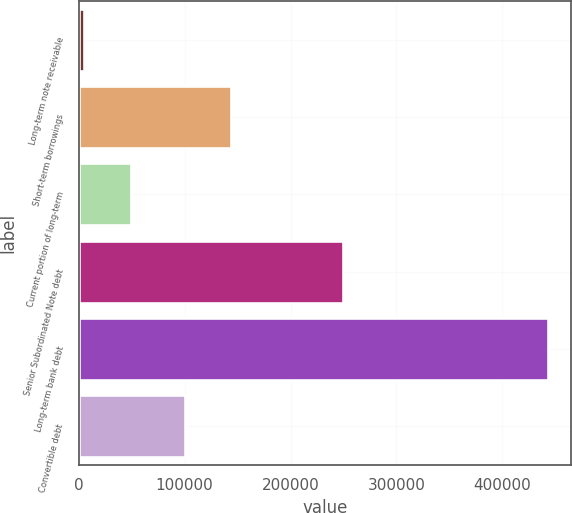Convert chart to OTSL. <chart><loc_0><loc_0><loc_500><loc_500><bar_chart><fcel>Long-term note receivable<fcel>Short-term borrowings<fcel>Current portion of long-term<fcel>Senior Subordinated Note debt<fcel>Long-term bank debt<fcel>Convertible debt<nl><fcel>5226<fcel>143770<fcel>48995.9<fcel>250000<fcel>442925<fcel>100000<nl></chart> 